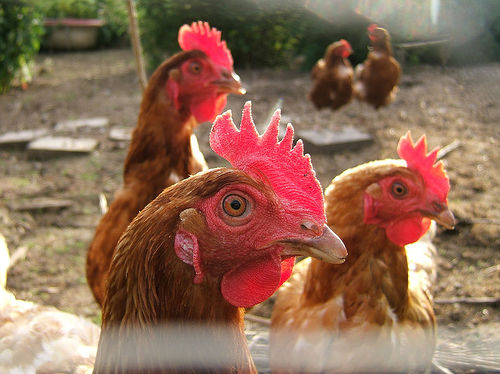<image>
Can you confirm if the cock is next to the cock? Yes. The cock is positioned adjacent to the cock, located nearby in the same general area. Where is the chicken in relation to the chicken? Is it on the chicken? No. The chicken is not positioned on the chicken. They may be near each other, but the chicken is not supported by or resting on top of the chicken. Where is the chicken in relation to the chicken? Is it to the left of the chicken? No. The chicken is not to the left of the chicken. From this viewpoint, they have a different horizontal relationship. 